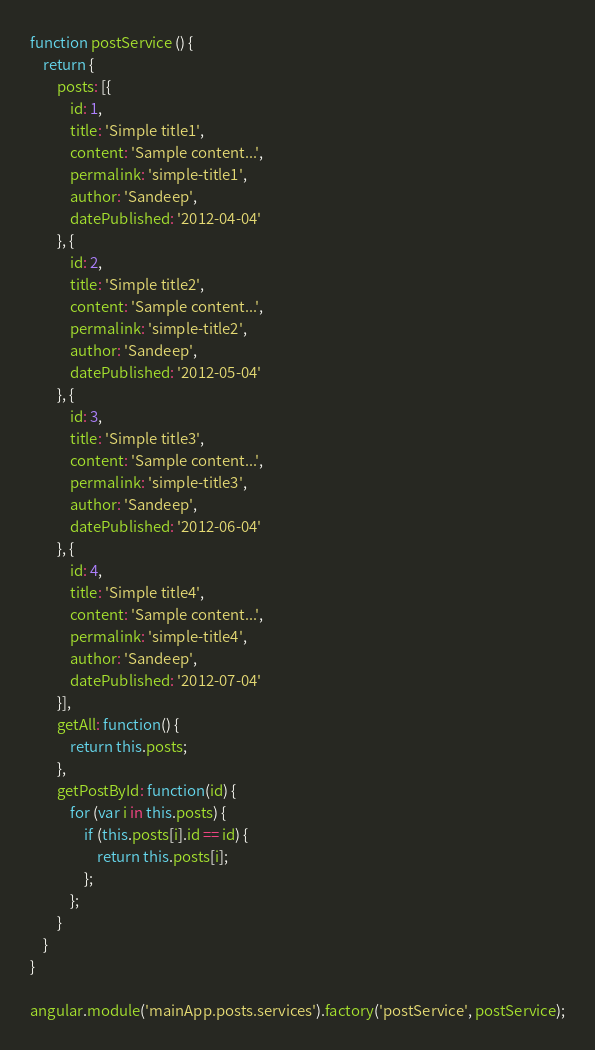Convert code to text. <code><loc_0><loc_0><loc_500><loc_500><_JavaScript_>function postService () {
	return {
		posts: [{
			id: 1,
			title: 'Simple title1',
			content: 'Sample content...',
			permalink: 'simple-title1',
			author: 'Sandeep',
			datePublished: '2012-04-04'
		}, {
			id: 2,
			title: 'Simple title2',
			content: 'Sample content...',
			permalink: 'simple-title2',
			author: 'Sandeep',
			datePublished: '2012-05-04'
		}, {
			id: 3,
			title: 'Simple title3',
			content: 'Sample content...',
			permalink: 'simple-title3',
			author: 'Sandeep',
			datePublished: '2012-06-04'
		}, {
			id: 4,
			title: 'Simple title4',
			content: 'Sample content...',
			permalink: 'simple-title4',
			author: 'Sandeep',
			datePublished: '2012-07-04'
		}], 
		getAll: function() {
			return this.posts;
		},
		getPostById: function(id) {
			for (var i in this.posts) {
				if (this.posts[i].id == id) {
					return this.posts[i];
				};
			};
		}
	}
}

angular.module('mainApp.posts.services').factory('postService', postService);
</code> 